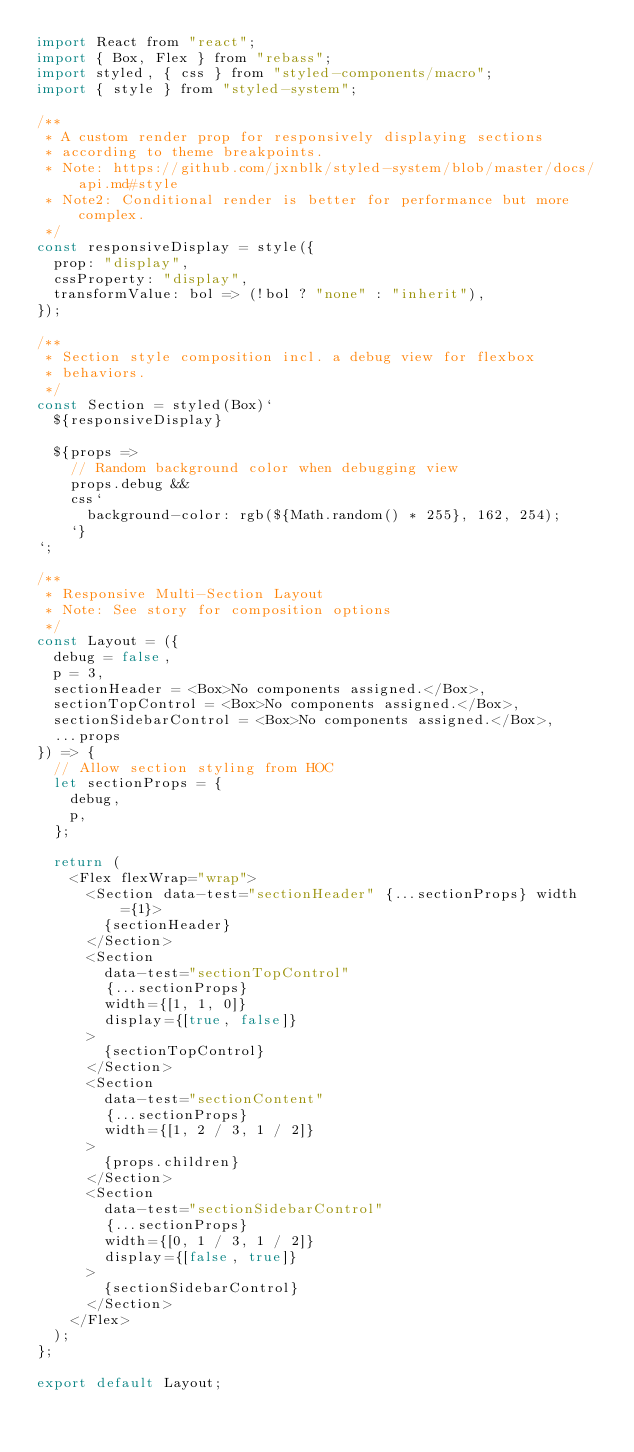Convert code to text. <code><loc_0><loc_0><loc_500><loc_500><_JavaScript_>import React from "react";
import { Box, Flex } from "rebass";
import styled, { css } from "styled-components/macro";
import { style } from "styled-system";

/**
 * A custom render prop for responsively displaying sections
 * according to theme breakpoints.
 * Note: https://github.com/jxnblk/styled-system/blob/master/docs/api.md#style
 * Note2: Conditional render is better for performance but more complex.
 */
const responsiveDisplay = style({
  prop: "display",
  cssProperty: "display",
  transformValue: bol => (!bol ? "none" : "inherit"),
});

/**
 * Section style composition incl. a debug view for flexbox
 * behaviors.
 */
const Section = styled(Box)`
  ${responsiveDisplay}

  ${props =>
    // Random background color when debugging view
    props.debug &&
    css`
      background-color: rgb(${Math.random() * 255}, 162, 254);
    `}
`;

/**
 * Responsive Multi-Section Layout
 * Note: See story for composition options
 */
const Layout = ({
  debug = false,
  p = 3,
  sectionHeader = <Box>No components assigned.</Box>,
  sectionTopControl = <Box>No components assigned.</Box>,
  sectionSidebarControl = <Box>No components assigned.</Box>,
  ...props
}) => {
  // Allow section styling from HOC
  let sectionProps = {
    debug,
    p,
  };

  return (
    <Flex flexWrap="wrap">
      <Section data-test="sectionHeader" {...sectionProps} width={1}>
        {sectionHeader}
      </Section>
      <Section
        data-test="sectionTopControl"
        {...sectionProps}
        width={[1, 1, 0]}
        display={[true, false]}
      >
        {sectionTopControl}
      </Section>
      <Section
        data-test="sectionContent"
        {...sectionProps}
        width={[1, 2 / 3, 1 / 2]}
      >
        {props.children}
      </Section>
      <Section
        data-test="sectionSidebarControl"
        {...sectionProps}
        width={[0, 1 / 3, 1 / 2]}
        display={[false, true]}
      >
        {sectionSidebarControl}
      </Section>
    </Flex>
  );
};

export default Layout;
</code> 